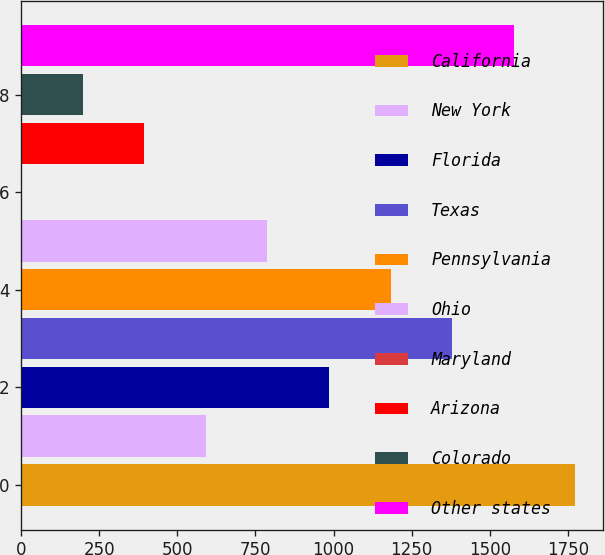Convert chart. <chart><loc_0><loc_0><loc_500><loc_500><bar_chart><fcel>California<fcel>New York<fcel>Florida<fcel>Texas<fcel>Pennsylvania<fcel>Ohio<fcel>Maryland<fcel>Arizona<fcel>Colorado<fcel>Other states<nl><fcel>1773.1<fcel>591.7<fcel>985.5<fcel>1379.3<fcel>1182.4<fcel>788.6<fcel>1<fcel>394.8<fcel>197.9<fcel>1576.2<nl></chart> 